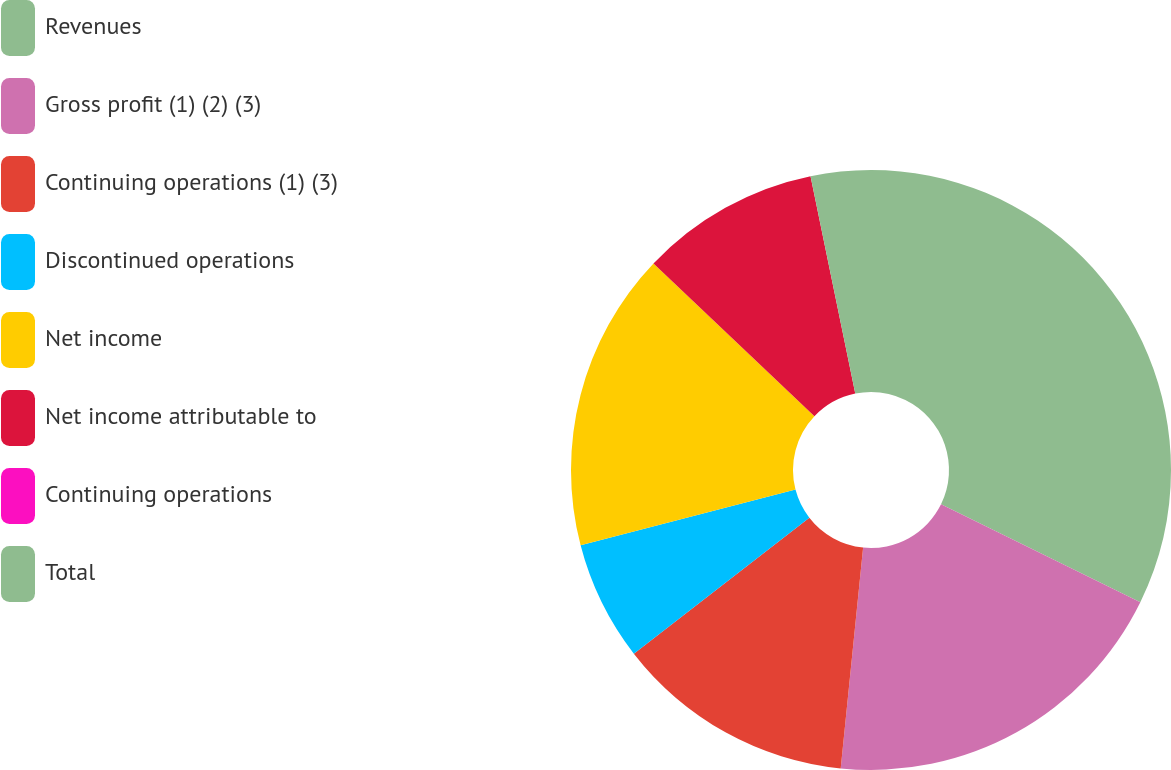Convert chart. <chart><loc_0><loc_0><loc_500><loc_500><pie_chart><fcel>Revenues<fcel>Gross profit (1) (2) (3)<fcel>Continuing operations (1) (3)<fcel>Discontinued operations<fcel>Net income<fcel>Net income attributable to<fcel>Continuing operations<fcel>Total<nl><fcel>32.26%<fcel>19.35%<fcel>12.9%<fcel>6.45%<fcel>16.13%<fcel>9.68%<fcel>0.0%<fcel>3.23%<nl></chart> 